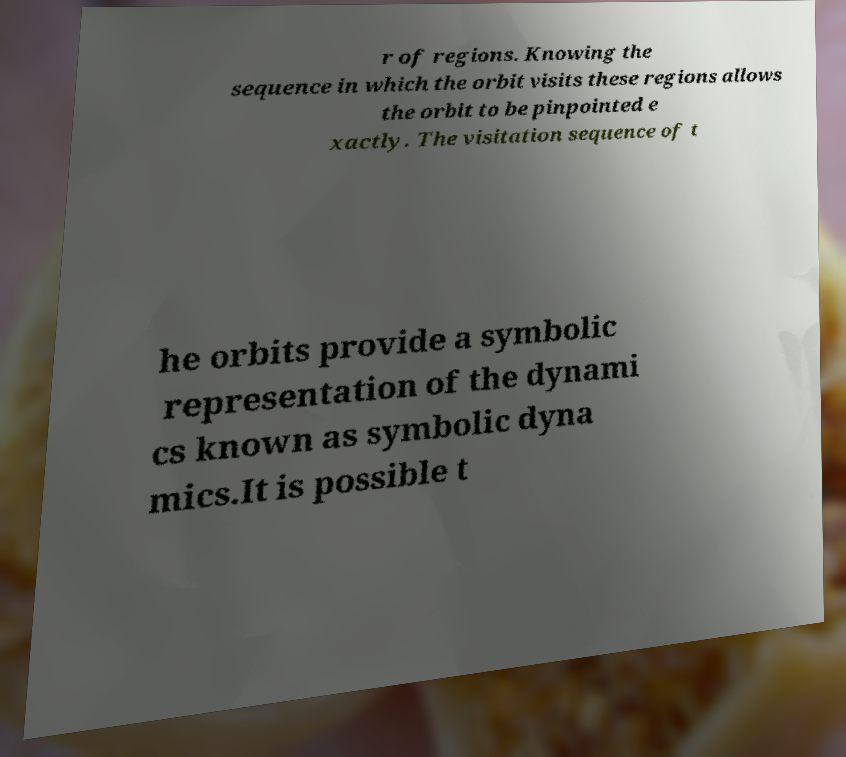Can you read and provide the text displayed in the image?This photo seems to have some interesting text. Can you extract and type it out for me? r of regions. Knowing the sequence in which the orbit visits these regions allows the orbit to be pinpointed e xactly. The visitation sequence of t he orbits provide a symbolic representation of the dynami cs known as symbolic dyna mics.It is possible t 